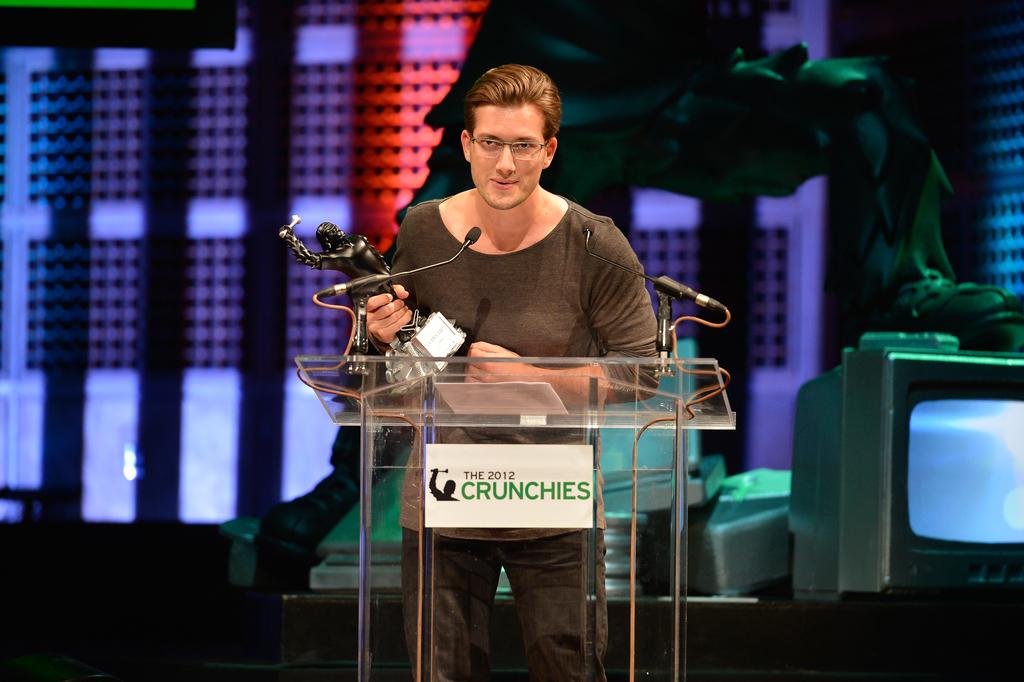What year is on the sign?
Your answer should be compact. 2012. 